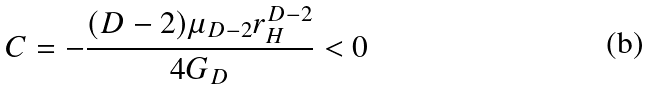<formula> <loc_0><loc_0><loc_500><loc_500>C = - \frac { ( D - 2 ) \mu _ { D - 2 } r ^ { D - 2 } _ { H } } { 4 G _ { D } } < 0</formula> 